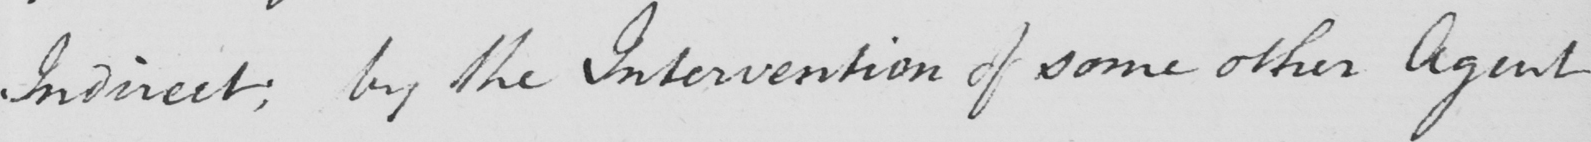What is written in this line of handwriting? Indirect ; by the Intervention of some other Agent 